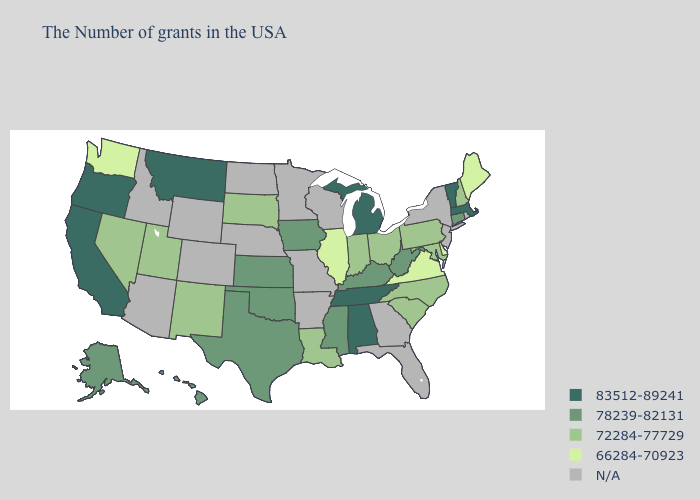Name the states that have a value in the range 66284-70923?
Write a very short answer. Maine, Delaware, Virginia, Illinois, Washington. Does Hawaii have the lowest value in the USA?
Short answer required. No. Name the states that have a value in the range 83512-89241?
Concise answer only. Massachusetts, Vermont, Michigan, Alabama, Tennessee, Montana, California, Oregon. Name the states that have a value in the range 72284-77729?
Be succinct. New Hampshire, Maryland, Pennsylvania, North Carolina, South Carolina, Ohio, Indiana, Louisiana, South Dakota, New Mexico, Utah, Nevada. Name the states that have a value in the range 72284-77729?
Concise answer only. New Hampshire, Maryland, Pennsylvania, North Carolina, South Carolina, Ohio, Indiana, Louisiana, South Dakota, New Mexico, Utah, Nevada. Name the states that have a value in the range N/A?
Quick response, please. Rhode Island, New York, New Jersey, Florida, Georgia, Wisconsin, Missouri, Arkansas, Minnesota, Nebraska, North Dakota, Wyoming, Colorado, Arizona, Idaho. Which states have the lowest value in the South?
Give a very brief answer. Delaware, Virginia. What is the value of Alabama?
Write a very short answer. 83512-89241. Among the states that border Georgia , does Alabama have the highest value?
Answer briefly. Yes. Does Illinois have the lowest value in the MidWest?
Concise answer only. Yes. Among the states that border Maryland , does Virginia have the lowest value?
Short answer required. Yes. Does Michigan have the highest value in the MidWest?
Short answer required. Yes. Name the states that have a value in the range N/A?
Quick response, please. Rhode Island, New York, New Jersey, Florida, Georgia, Wisconsin, Missouri, Arkansas, Minnesota, Nebraska, North Dakota, Wyoming, Colorado, Arizona, Idaho. 